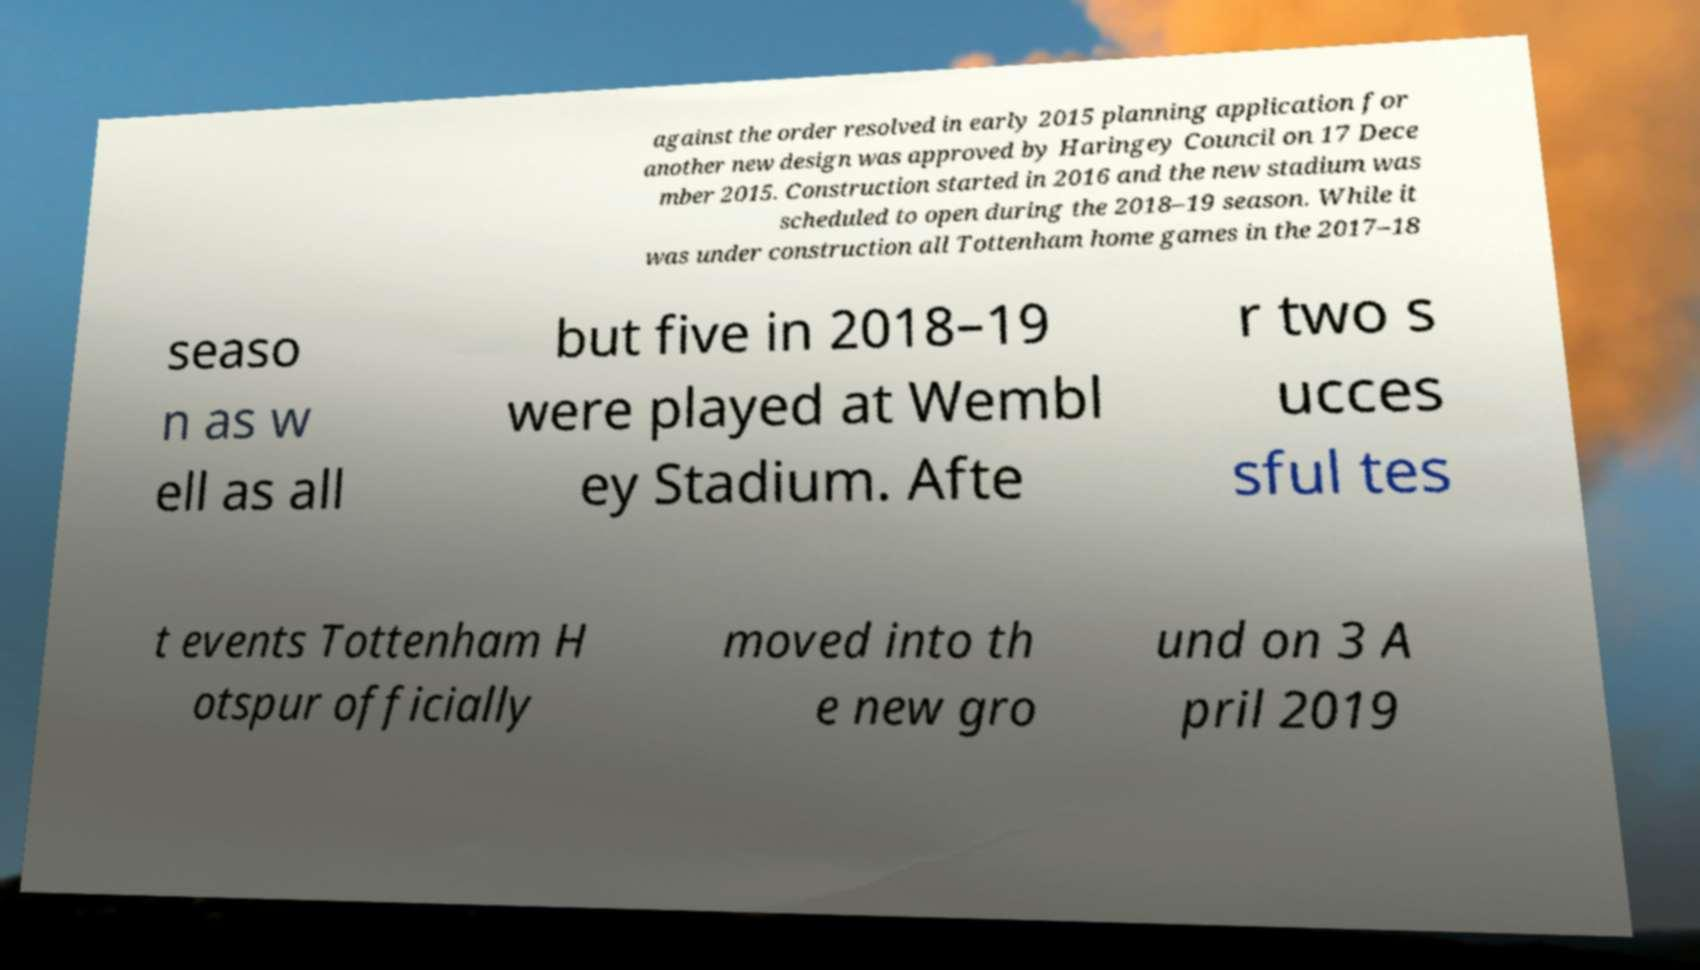For documentation purposes, I need the text within this image transcribed. Could you provide that? against the order resolved in early 2015 planning application for another new design was approved by Haringey Council on 17 Dece mber 2015. Construction started in 2016 and the new stadium was scheduled to open during the 2018–19 season. While it was under construction all Tottenham home games in the 2017–18 seaso n as w ell as all but five in 2018–19 were played at Wembl ey Stadium. Afte r two s ucces sful tes t events Tottenham H otspur officially moved into th e new gro und on 3 A pril 2019 